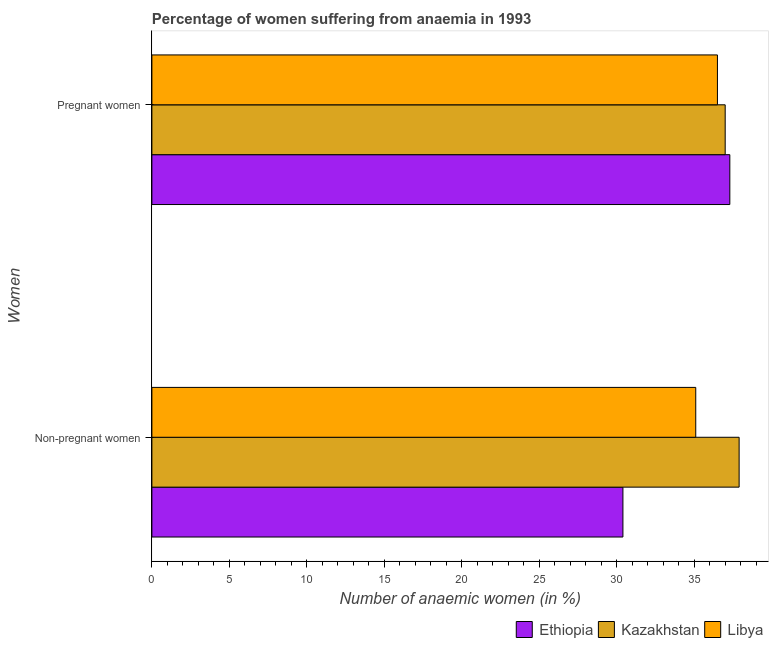How many different coloured bars are there?
Your answer should be compact. 3. Are the number of bars per tick equal to the number of legend labels?
Provide a succinct answer. Yes. Are the number of bars on each tick of the Y-axis equal?
Make the answer very short. Yes. How many bars are there on the 2nd tick from the bottom?
Offer a very short reply. 3. What is the label of the 1st group of bars from the top?
Make the answer very short. Pregnant women. What is the percentage of pregnant anaemic women in Libya?
Keep it short and to the point. 36.5. Across all countries, what is the maximum percentage of non-pregnant anaemic women?
Keep it short and to the point. 37.9. Across all countries, what is the minimum percentage of non-pregnant anaemic women?
Keep it short and to the point. 30.4. In which country was the percentage of non-pregnant anaemic women maximum?
Give a very brief answer. Kazakhstan. In which country was the percentage of pregnant anaemic women minimum?
Your response must be concise. Libya. What is the total percentage of pregnant anaemic women in the graph?
Ensure brevity in your answer.  110.8. What is the difference between the percentage of pregnant anaemic women in Ethiopia and that in Kazakhstan?
Provide a short and direct response. 0.3. What is the difference between the percentage of pregnant anaemic women in Kazakhstan and the percentage of non-pregnant anaemic women in Libya?
Provide a short and direct response. 1.9. What is the average percentage of pregnant anaemic women per country?
Ensure brevity in your answer.  36.93. What is the difference between the percentage of pregnant anaemic women and percentage of non-pregnant anaemic women in Libya?
Offer a terse response. 1.4. In how many countries, is the percentage of pregnant anaemic women greater than 33 %?
Ensure brevity in your answer.  3. What is the ratio of the percentage of pregnant anaemic women in Ethiopia to that in Libya?
Provide a succinct answer. 1.02. Is the percentage of pregnant anaemic women in Ethiopia less than that in Libya?
Give a very brief answer. No. In how many countries, is the percentage of pregnant anaemic women greater than the average percentage of pregnant anaemic women taken over all countries?
Provide a short and direct response. 2. What does the 3rd bar from the top in Non-pregnant women represents?
Your response must be concise. Ethiopia. What does the 1st bar from the bottom in Non-pregnant women represents?
Keep it short and to the point. Ethiopia. How many bars are there?
Offer a terse response. 6. How many countries are there in the graph?
Your answer should be compact. 3. Are the values on the major ticks of X-axis written in scientific E-notation?
Your response must be concise. No. Does the graph contain grids?
Your answer should be very brief. No. Where does the legend appear in the graph?
Your response must be concise. Bottom right. How are the legend labels stacked?
Your response must be concise. Horizontal. What is the title of the graph?
Your answer should be compact. Percentage of women suffering from anaemia in 1993. What is the label or title of the X-axis?
Your answer should be very brief. Number of anaemic women (in %). What is the label or title of the Y-axis?
Keep it short and to the point. Women. What is the Number of anaemic women (in %) of Ethiopia in Non-pregnant women?
Make the answer very short. 30.4. What is the Number of anaemic women (in %) in Kazakhstan in Non-pregnant women?
Your answer should be very brief. 37.9. What is the Number of anaemic women (in %) in Libya in Non-pregnant women?
Keep it short and to the point. 35.1. What is the Number of anaemic women (in %) of Ethiopia in Pregnant women?
Offer a terse response. 37.3. What is the Number of anaemic women (in %) of Libya in Pregnant women?
Give a very brief answer. 36.5. Across all Women, what is the maximum Number of anaemic women (in %) in Ethiopia?
Your answer should be very brief. 37.3. Across all Women, what is the maximum Number of anaemic women (in %) in Kazakhstan?
Your answer should be very brief. 37.9. Across all Women, what is the maximum Number of anaemic women (in %) of Libya?
Offer a very short reply. 36.5. Across all Women, what is the minimum Number of anaemic women (in %) in Ethiopia?
Keep it short and to the point. 30.4. Across all Women, what is the minimum Number of anaemic women (in %) in Libya?
Your answer should be compact. 35.1. What is the total Number of anaemic women (in %) of Ethiopia in the graph?
Offer a very short reply. 67.7. What is the total Number of anaemic women (in %) in Kazakhstan in the graph?
Your response must be concise. 74.9. What is the total Number of anaemic women (in %) in Libya in the graph?
Provide a succinct answer. 71.6. What is the difference between the Number of anaemic women (in %) in Kazakhstan in Non-pregnant women and that in Pregnant women?
Provide a short and direct response. 0.9. What is the difference between the Number of anaemic women (in %) of Ethiopia in Non-pregnant women and the Number of anaemic women (in %) of Kazakhstan in Pregnant women?
Your answer should be compact. -6.6. What is the average Number of anaemic women (in %) in Ethiopia per Women?
Ensure brevity in your answer.  33.85. What is the average Number of anaemic women (in %) of Kazakhstan per Women?
Give a very brief answer. 37.45. What is the average Number of anaemic women (in %) in Libya per Women?
Your response must be concise. 35.8. What is the difference between the Number of anaemic women (in %) of Ethiopia and Number of anaemic women (in %) of Kazakhstan in Non-pregnant women?
Offer a terse response. -7.5. What is the difference between the Number of anaemic women (in %) of Kazakhstan and Number of anaemic women (in %) of Libya in Non-pregnant women?
Provide a short and direct response. 2.8. What is the difference between the Number of anaemic women (in %) of Kazakhstan and Number of anaemic women (in %) of Libya in Pregnant women?
Offer a terse response. 0.5. What is the ratio of the Number of anaemic women (in %) in Ethiopia in Non-pregnant women to that in Pregnant women?
Provide a succinct answer. 0.81. What is the ratio of the Number of anaemic women (in %) in Kazakhstan in Non-pregnant women to that in Pregnant women?
Provide a succinct answer. 1.02. What is the ratio of the Number of anaemic women (in %) of Libya in Non-pregnant women to that in Pregnant women?
Your answer should be compact. 0.96. What is the difference between the highest and the second highest Number of anaemic women (in %) of Ethiopia?
Provide a short and direct response. 6.9. What is the difference between the highest and the second highest Number of anaemic women (in %) of Kazakhstan?
Your response must be concise. 0.9. What is the difference between the highest and the lowest Number of anaemic women (in %) of Ethiopia?
Keep it short and to the point. 6.9. What is the difference between the highest and the lowest Number of anaemic women (in %) in Libya?
Make the answer very short. 1.4. 